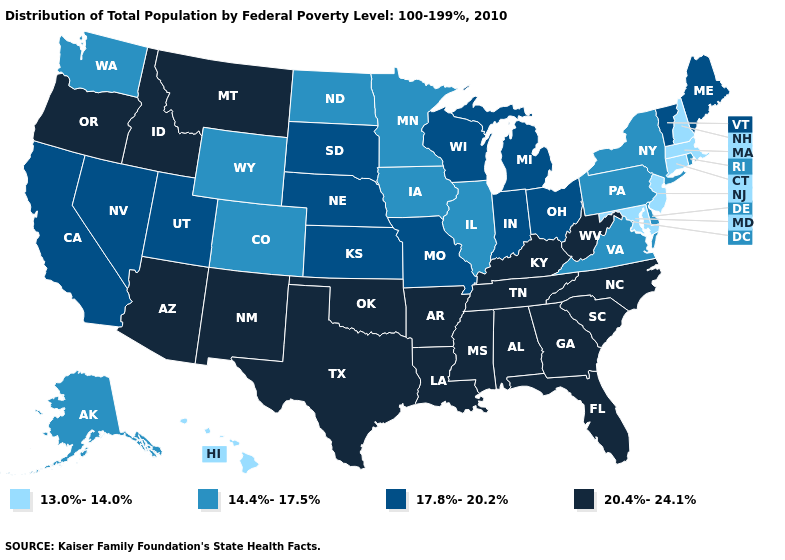What is the highest value in states that border Tennessee?
Give a very brief answer. 20.4%-24.1%. Does the map have missing data?
Short answer required. No. Among the states that border Missouri , does Illinois have the lowest value?
Give a very brief answer. Yes. Name the states that have a value in the range 17.8%-20.2%?
Concise answer only. California, Indiana, Kansas, Maine, Michigan, Missouri, Nebraska, Nevada, Ohio, South Dakota, Utah, Vermont, Wisconsin. Does Utah have a higher value than Maryland?
Quick response, please. Yes. What is the value of Nevada?
Give a very brief answer. 17.8%-20.2%. Name the states that have a value in the range 17.8%-20.2%?
Concise answer only. California, Indiana, Kansas, Maine, Michigan, Missouri, Nebraska, Nevada, Ohio, South Dakota, Utah, Vermont, Wisconsin. Which states have the lowest value in the South?
Keep it brief. Maryland. What is the highest value in states that border Massachusetts?
Quick response, please. 17.8%-20.2%. What is the value of New Mexico?
Quick response, please. 20.4%-24.1%. Name the states that have a value in the range 17.8%-20.2%?
Be succinct. California, Indiana, Kansas, Maine, Michigan, Missouri, Nebraska, Nevada, Ohio, South Dakota, Utah, Vermont, Wisconsin. How many symbols are there in the legend?
Be succinct. 4. Does the map have missing data?
Answer briefly. No. Which states have the highest value in the USA?
Quick response, please. Alabama, Arizona, Arkansas, Florida, Georgia, Idaho, Kentucky, Louisiana, Mississippi, Montana, New Mexico, North Carolina, Oklahoma, Oregon, South Carolina, Tennessee, Texas, West Virginia. What is the lowest value in the MidWest?
Give a very brief answer. 14.4%-17.5%. 